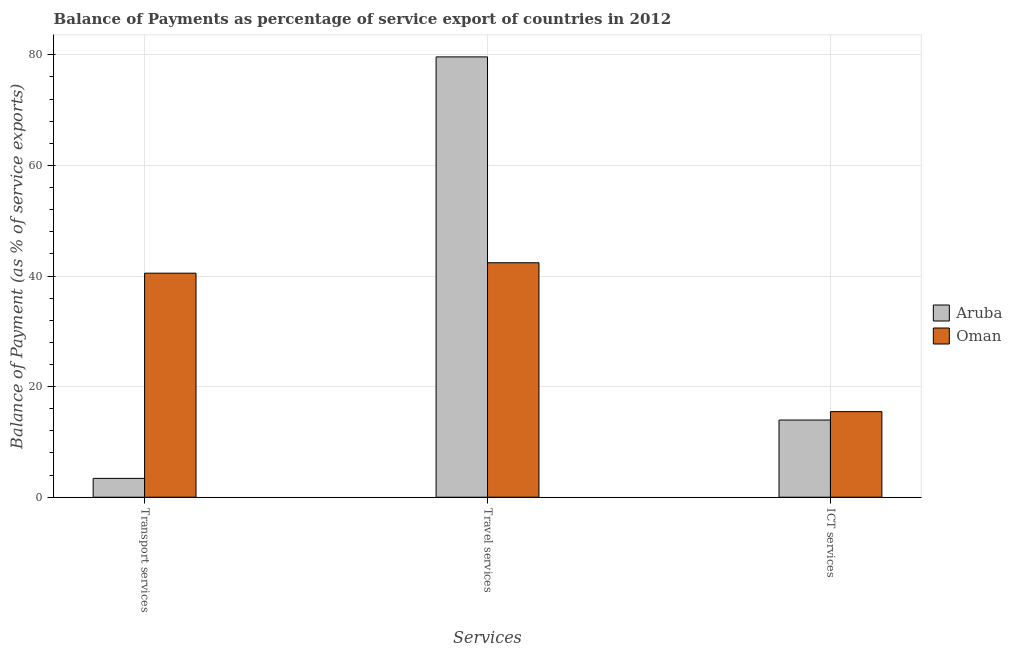How many groups of bars are there?
Make the answer very short. 3. Are the number of bars on each tick of the X-axis equal?
Provide a succinct answer. Yes. How many bars are there on the 2nd tick from the left?
Your response must be concise. 2. How many bars are there on the 3rd tick from the right?
Your answer should be very brief. 2. What is the label of the 1st group of bars from the left?
Give a very brief answer. Transport services. What is the balance of payment of transport services in Oman?
Offer a very short reply. 40.51. Across all countries, what is the maximum balance of payment of travel services?
Offer a terse response. 79.62. Across all countries, what is the minimum balance of payment of transport services?
Your response must be concise. 3.41. In which country was the balance of payment of ict services maximum?
Keep it short and to the point. Oman. In which country was the balance of payment of ict services minimum?
Make the answer very short. Aruba. What is the total balance of payment of travel services in the graph?
Keep it short and to the point. 122.02. What is the difference between the balance of payment of transport services in Aruba and that in Oman?
Make the answer very short. -37.11. What is the difference between the balance of payment of transport services in Aruba and the balance of payment of travel services in Oman?
Your answer should be compact. -38.99. What is the average balance of payment of travel services per country?
Your answer should be very brief. 61.01. What is the difference between the balance of payment of transport services and balance of payment of travel services in Oman?
Your answer should be compact. -1.88. What is the ratio of the balance of payment of travel services in Aruba to that in Oman?
Provide a succinct answer. 1.88. What is the difference between the highest and the second highest balance of payment of travel services?
Keep it short and to the point. 37.23. What is the difference between the highest and the lowest balance of payment of ict services?
Your answer should be very brief. 1.52. What does the 1st bar from the left in ICT services represents?
Your answer should be compact. Aruba. What does the 1st bar from the right in ICT services represents?
Provide a short and direct response. Oman. Is it the case that in every country, the sum of the balance of payment of transport services and balance of payment of travel services is greater than the balance of payment of ict services?
Give a very brief answer. Yes. Are all the bars in the graph horizontal?
Your response must be concise. No. How many countries are there in the graph?
Offer a very short reply. 2. Does the graph contain grids?
Your answer should be very brief. Yes. Where does the legend appear in the graph?
Your answer should be very brief. Center right. What is the title of the graph?
Make the answer very short. Balance of Payments as percentage of service export of countries in 2012. Does "High income: nonOECD" appear as one of the legend labels in the graph?
Offer a terse response. No. What is the label or title of the X-axis?
Your answer should be compact. Services. What is the label or title of the Y-axis?
Provide a short and direct response. Balance of Payment (as % of service exports). What is the Balance of Payment (as % of service exports) of Aruba in Transport services?
Your response must be concise. 3.41. What is the Balance of Payment (as % of service exports) in Oman in Transport services?
Give a very brief answer. 40.51. What is the Balance of Payment (as % of service exports) of Aruba in Travel services?
Make the answer very short. 79.62. What is the Balance of Payment (as % of service exports) in Oman in Travel services?
Offer a terse response. 42.4. What is the Balance of Payment (as % of service exports) in Aruba in ICT services?
Ensure brevity in your answer.  13.96. What is the Balance of Payment (as % of service exports) in Oman in ICT services?
Provide a succinct answer. 15.48. Across all Services, what is the maximum Balance of Payment (as % of service exports) in Aruba?
Offer a terse response. 79.62. Across all Services, what is the maximum Balance of Payment (as % of service exports) of Oman?
Your response must be concise. 42.4. Across all Services, what is the minimum Balance of Payment (as % of service exports) in Aruba?
Give a very brief answer. 3.41. Across all Services, what is the minimum Balance of Payment (as % of service exports) in Oman?
Give a very brief answer. 15.48. What is the total Balance of Payment (as % of service exports) in Aruba in the graph?
Your answer should be compact. 96.99. What is the total Balance of Payment (as % of service exports) of Oman in the graph?
Offer a terse response. 98.39. What is the difference between the Balance of Payment (as % of service exports) of Aruba in Transport services and that in Travel services?
Your answer should be very brief. -76.22. What is the difference between the Balance of Payment (as % of service exports) in Oman in Transport services and that in Travel services?
Offer a terse response. -1.88. What is the difference between the Balance of Payment (as % of service exports) in Aruba in Transport services and that in ICT services?
Make the answer very short. -10.55. What is the difference between the Balance of Payment (as % of service exports) of Oman in Transport services and that in ICT services?
Provide a short and direct response. 25.03. What is the difference between the Balance of Payment (as % of service exports) of Aruba in Travel services and that in ICT services?
Provide a succinct answer. 65.67. What is the difference between the Balance of Payment (as % of service exports) in Oman in Travel services and that in ICT services?
Your response must be concise. 26.92. What is the difference between the Balance of Payment (as % of service exports) of Aruba in Transport services and the Balance of Payment (as % of service exports) of Oman in Travel services?
Keep it short and to the point. -38.99. What is the difference between the Balance of Payment (as % of service exports) in Aruba in Transport services and the Balance of Payment (as % of service exports) in Oman in ICT services?
Your answer should be compact. -12.07. What is the difference between the Balance of Payment (as % of service exports) of Aruba in Travel services and the Balance of Payment (as % of service exports) of Oman in ICT services?
Make the answer very short. 64.14. What is the average Balance of Payment (as % of service exports) of Aruba per Services?
Provide a succinct answer. 32.33. What is the average Balance of Payment (as % of service exports) in Oman per Services?
Your answer should be very brief. 32.8. What is the difference between the Balance of Payment (as % of service exports) in Aruba and Balance of Payment (as % of service exports) in Oman in Transport services?
Offer a terse response. -37.11. What is the difference between the Balance of Payment (as % of service exports) in Aruba and Balance of Payment (as % of service exports) in Oman in Travel services?
Keep it short and to the point. 37.23. What is the difference between the Balance of Payment (as % of service exports) of Aruba and Balance of Payment (as % of service exports) of Oman in ICT services?
Keep it short and to the point. -1.52. What is the ratio of the Balance of Payment (as % of service exports) of Aruba in Transport services to that in Travel services?
Make the answer very short. 0.04. What is the ratio of the Balance of Payment (as % of service exports) in Oman in Transport services to that in Travel services?
Give a very brief answer. 0.96. What is the ratio of the Balance of Payment (as % of service exports) in Aruba in Transport services to that in ICT services?
Your answer should be compact. 0.24. What is the ratio of the Balance of Payment (as % of service exports) in Oman in Transport services to that in ICT services?
Provide a short and direct response. 2.62. What is the ratio of the Balance of Payment (as % of service exports) of Aruba in Travel services to that in ICT services?
Your answer should be very brief. 5.71. What is the ratio of the Balance of Payment (as % of service exports) in Oman in Travel services to that in ICT services?
Offer a very short reply. 2.74. What is the difference between the highest and the second highest Balance of Payment (as % of service exports) in Aruba?
Ensure brevity in your answer.  65.67. What is the difference between the highest and the second highest Balance of Payment (as % of service exports) of Oman?
Give a very brief answer. 1.88. What is the difference between the highest and the lowest Balance of Payment (as % of service exports) in Aruba?
Make the answer very short. 76.22. What is the difference between the highest and the lowest Balance of Payment (as % of service exports) in Oman?
Give a very brief answer. 26.92. 